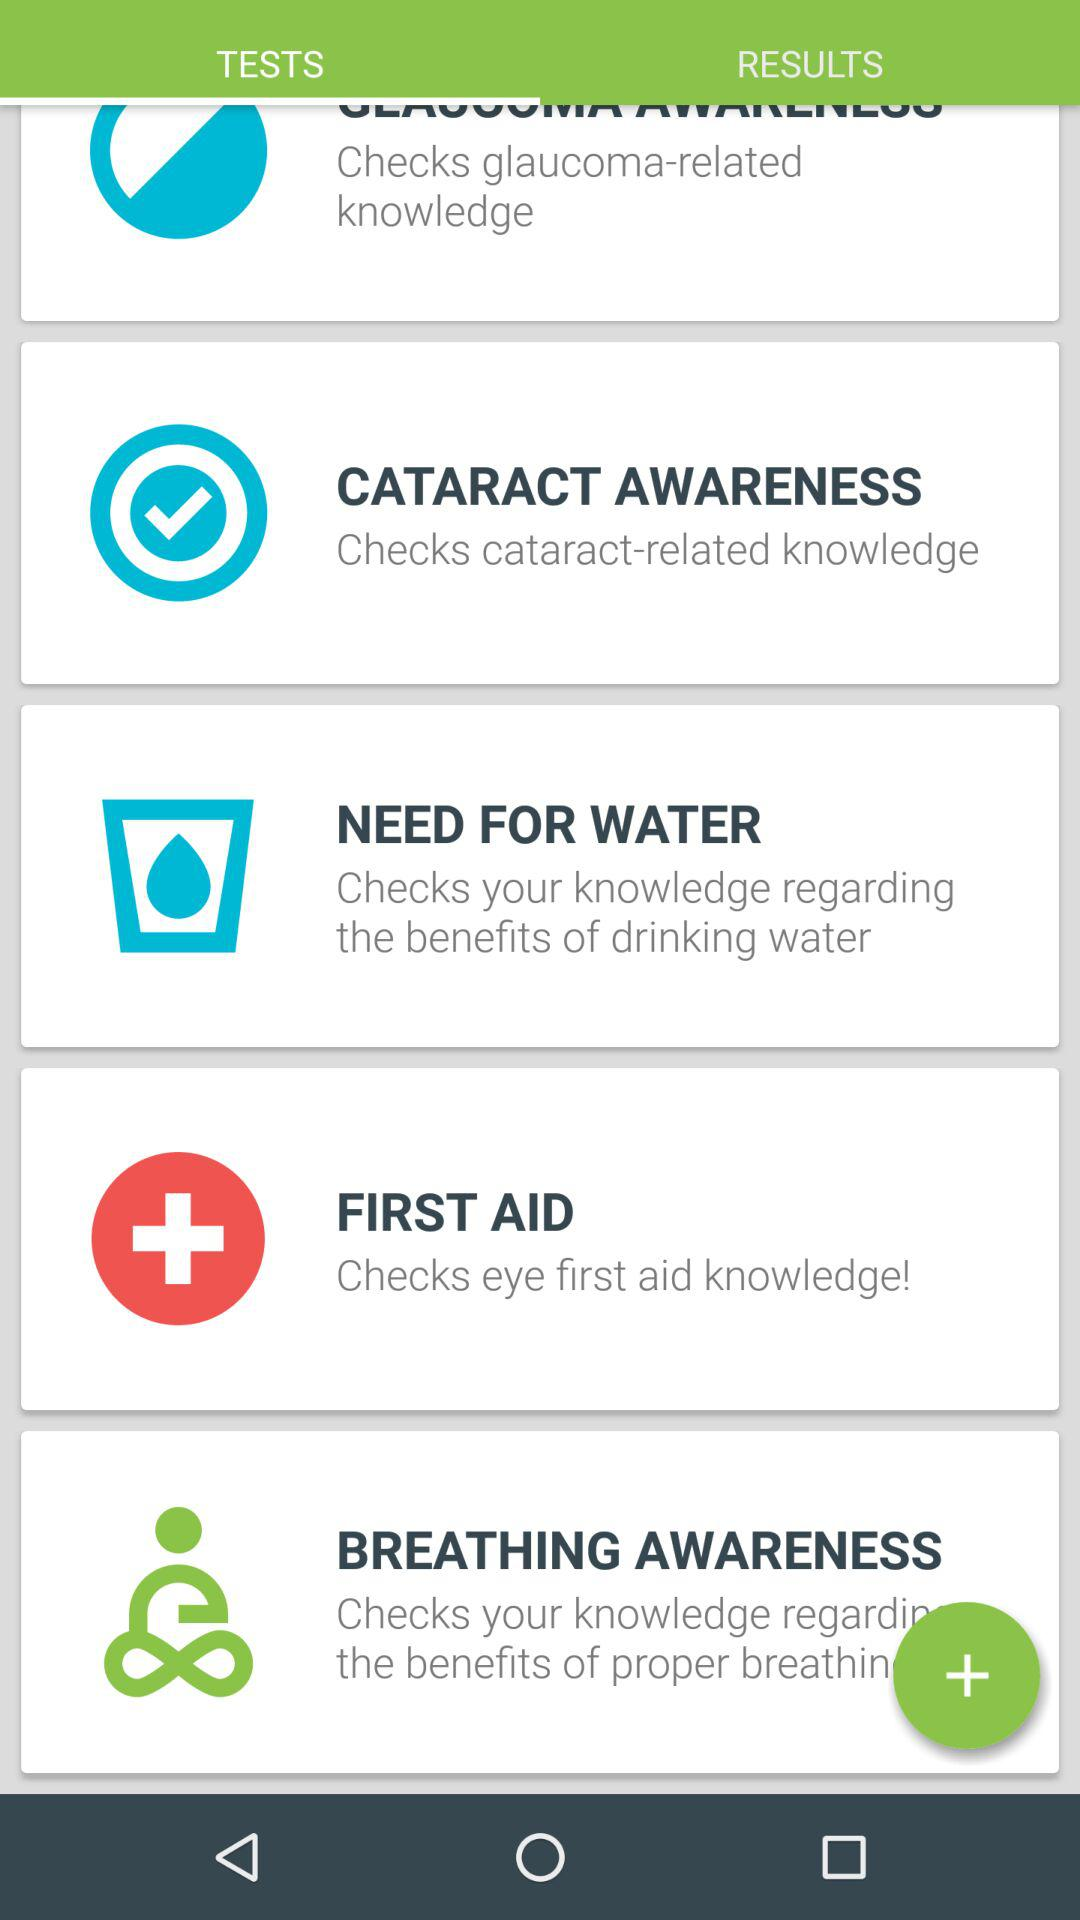What are the different test options available? The different test options available are "CATARACT AWARENESS", "NEED FOR WATER", "FIRST AID" and "BREATHING AWARENESS". 